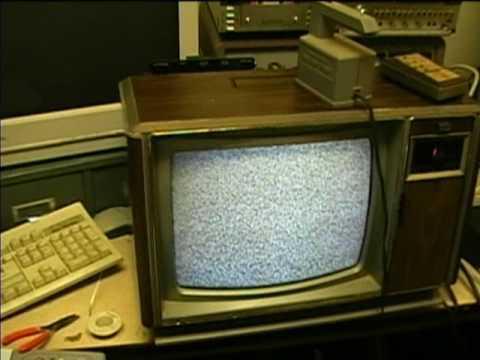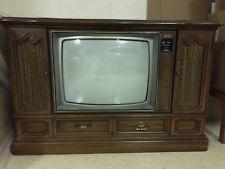The first image is the image on the left, the second image is the image on the right. Examine the images to the left and right. Is the description "At least one object sit atop the television in the image on the left." accurate? Answer yes or no. Yes. 